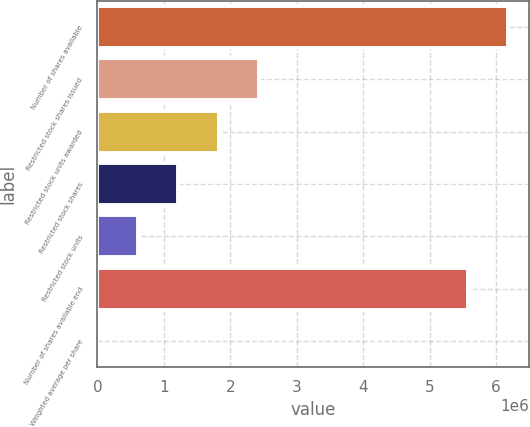<chart> <loc_0><loc_0><loc_500><loc_500><bar_chart><fcel>Number of shares available<fcel>Restricted stock shares issued<fcel>Restricted stock units awarded<fcel>Restricted stock shares<fcel>Restricted stock units<fcel>Number of shares available end<fcel>Weighted average per share<nl><fcel>6.18586e+06<fcel>2.43145e+06<fcel>1.82359e+06<fcel>1.21573e+06<fcel>607874<fcel>5.578e+06<fcel>16.33<nl></chart> 